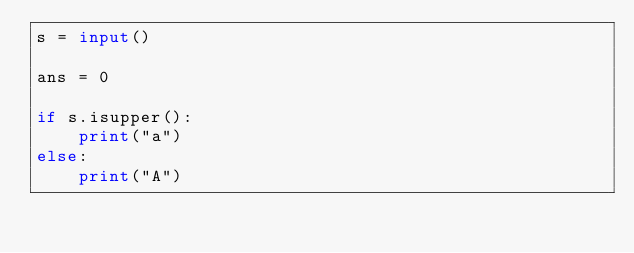<code> <loc_0><loc_0><loc_500><loc_500><_Python_>s = input()

ans = 0

if s.isupper():
    print("a")
else:
    print("A")</code> 